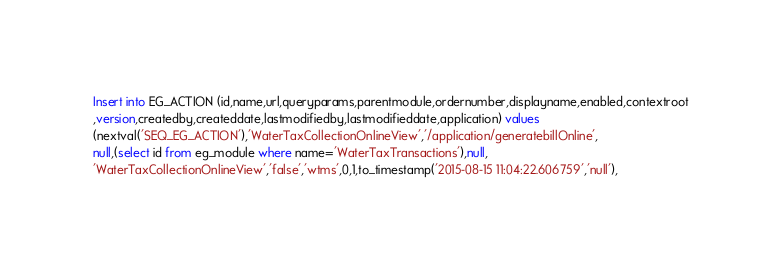<code> <loc_0><loc_0><loc_500><loc_500><_SQL_>Insert into EG_ACTION (id,name,url,queryparams,parentmodule,ordernumber,displayname,enabled,contextroot
,version,createdby,createddate,lastmodifiedby,lastmodifieddate,application) values 
(nextval('SEQ_EG_ACTION'),'WaterTaxCollectionOnlineView','/application/generatebillOnline',
null,(select id from eg_module where name='WaterTaxTransactions'),null,
'WaterTaxCollectionOnlineView','false','wtms',0,1,to_timestamp('2015-08-15 11:04:22.606759','null'),</code> 